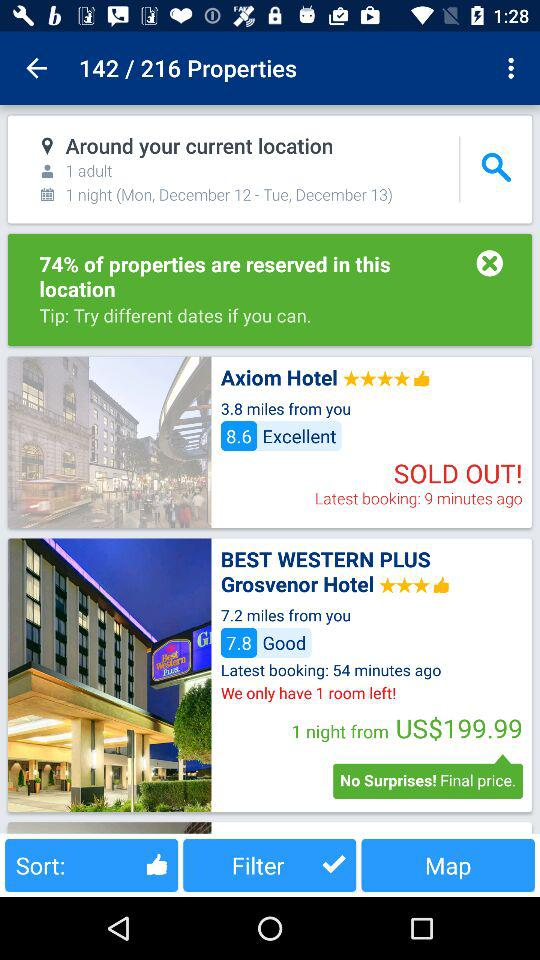Where are these hotels located on the map?
When the provided information is insufficient, respond with <no answer>. <no answer> 